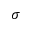<formula> <loc_0><loc_0><loc_500><loc_500>\sigma</formula> 